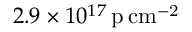<formula> <loc_0><loc_0><loc_500><loc_500>2 . 9 \times 1 0 ^ { 1 7 } \, p \, c m ^ { - 2 }</formula> 